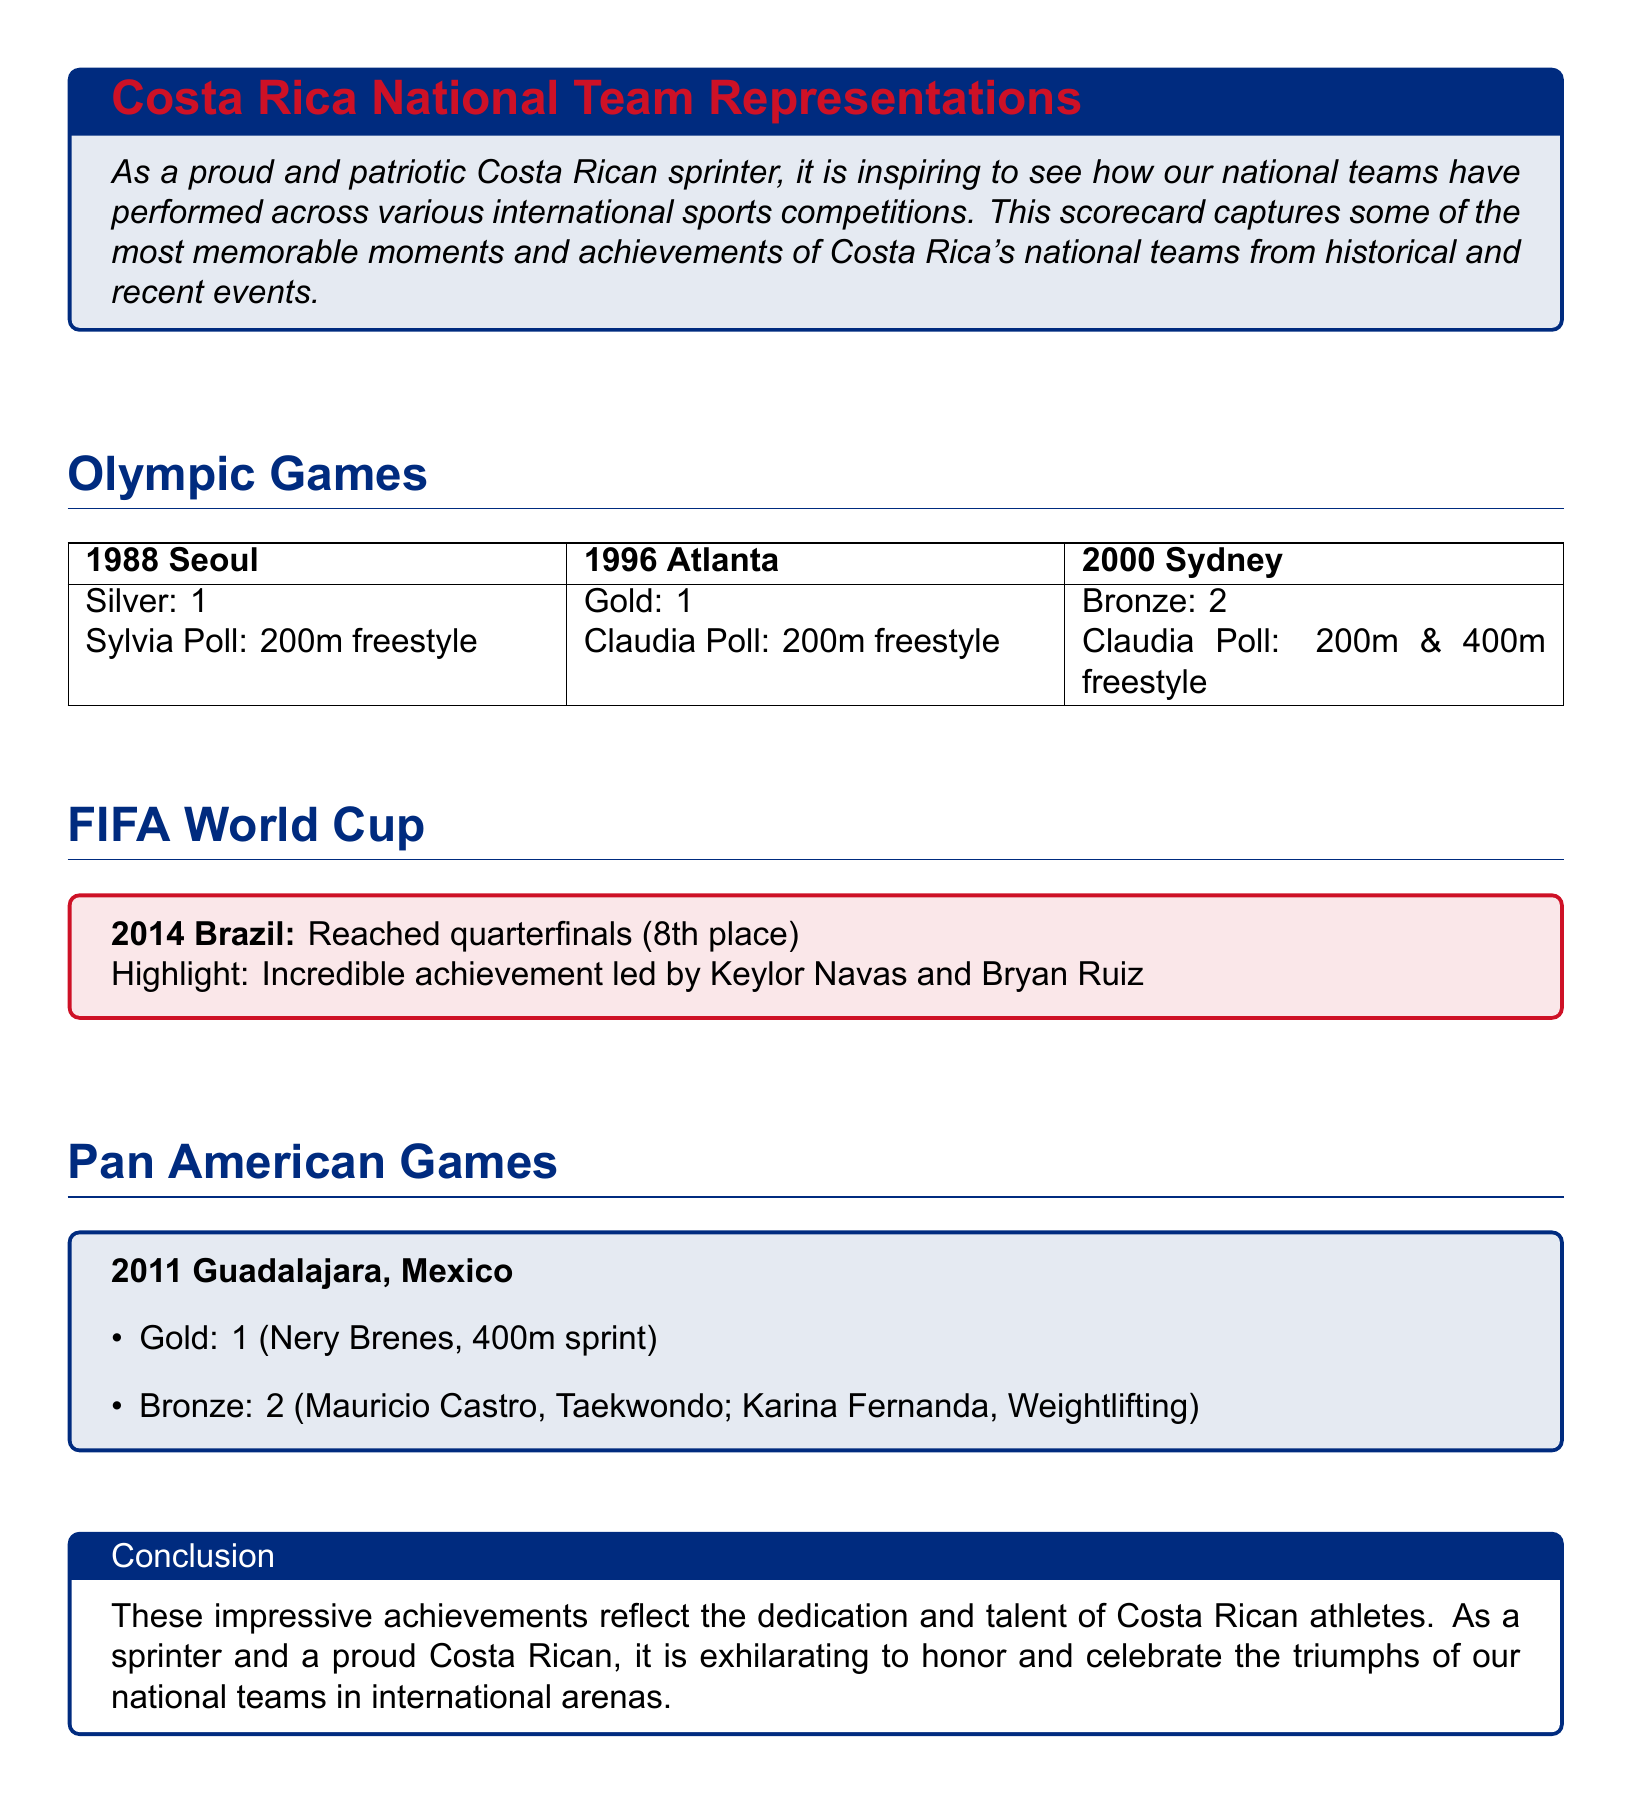What medal did Sylvia Poll win at the 1988 Seoul Olympics? The document states that Sylvia Poll won a Silver medal in the 200m freestyle at the 1988 Seoul Olympics.
Answer: Silver How many medals did Claudia Poll win in the 2000 Sydney Olympics? The document mentions that Claudia Poll won 2 medals (Bronze in 200m and 400m freestyle) at the 2000 Sydney Olympics.
Answer: 2 What place did Costa Rica achieve in the 2014 FIFA World Cup? The document indicates that Costa Rica reached the quarterfinals, finishing in 8th place in the 2014 FIFA World Cup.
Answer: 8th place Who won the Gold medal in the 2011 Pan American Games for Costa Rica? According to the document, Nery Brenes won the Gold medal in the 400m sprint at the 2011 Pan American Games.
Answer: Nery Brenes How many total medals did Costa Rica win in the 2011 Pan American Games? The document lists a total of 3 medals (1 Gold and 2 Bronze) for Costa Rica in the 2011 Pan American Games.
Answer: 3 What sport did Mauricio Castro compete in to win a medal in the 2011 Pan American Games? The document states that Mauricio Castro won a Bronze medal in Taekwondo at the 2011 Pan American Games.
Answer: Taekwondo Which notable Costa Rican athlete is mentioned in connection with the 2014 FIFA World Cup? The document highlights Keylor Navas's contribution as a notable athlete in the 2014 FIFA World Cup.
Answer: Keylor Navas What is the color of the box that features the conclusion section? The conclusion section is presented in a box colored with costarica2 (white).
Answer: white 